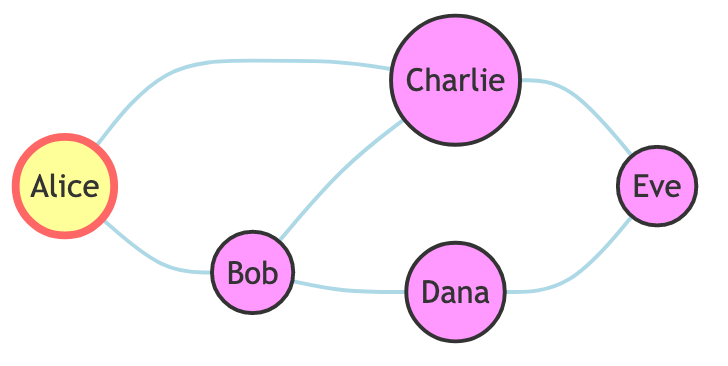What's the total number of students represented in the diagram? The diagram lists five nodes, each representing a student: Alice, Bob, Charlie, Dana, and Eve. Therefore, the total number of students is five.
Answer: 5 Which student is highlighted in the diagram? The node for Alice is highlighted, as indicated by the use of the highlighted class in the code. This signifies a distinction from other nodes.
Answer: Alice How many friendships does Bob have? By examining the edges connected to Bob, we see he connects to Alice, Charlie, and Dana, resulting in three friendships in total.
Answer: 3 Is there a direct friendship between Charlie and Eve? The edges show no direct connection between Charlie and Eve; instead, Charlie connects to Bob and Eve connects to Dana through separate friendships.
Answer: No Which two students have the most connections? Upon evaluating the nodes, Bob and Charlie each connect to three other students in the network, indicating they have the most friendships.
Answer: Bob and Charlie How many edges are present in the graph? The diagram depicts connections between students, and upon counting the edges, we find a total of six distinct connections.
Answer: 6 Which student is connected to both Dana and Eve? By checking the edges in the diagram, we find that Dana connects to Bob and Eve connects to both Charlie and Dana, making Charlie the student that connects to both.
Answer: Charlie Is there a student who is not directly connected to Alice? Analyzing the outgoing connections from Alice reveals her links to Bob and Charlie. However, she does not connect directly to Dana or Eve, thus either of those answers is valid.
Answer: Dana or Eve What is the relationship type represented in this graph? Since the edges in this diagram do not have directions (i.e., they are undirected), the relationship indicates mutual friendships among the students represented as nodes.
Answer: Mutual friendships 